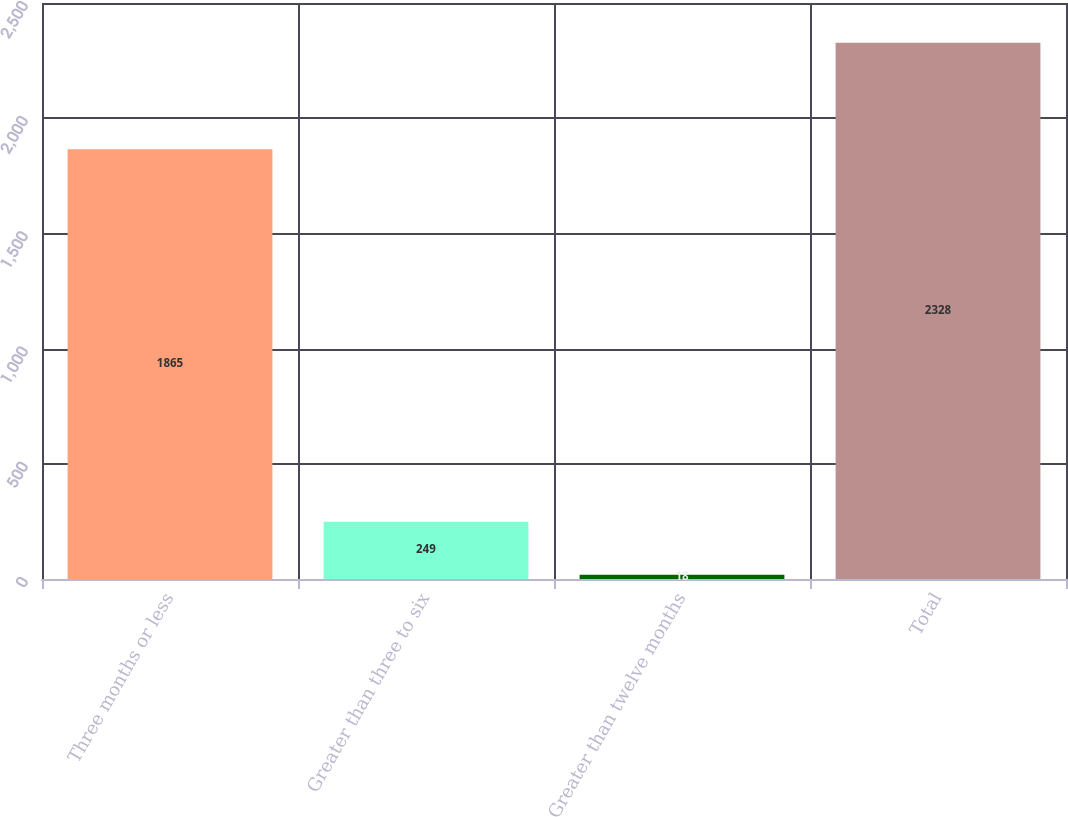Convert chart. <chart><loc_0><loc_0><loc_500><loc_500><bar_chart><fcel>Three months or less<fcel>Greater than three to six<fcel>Greater than twelve months<fcel>Total<nl><fcel>1865<fcel>249<fcel>18<fcel>2328<nl></chart> 